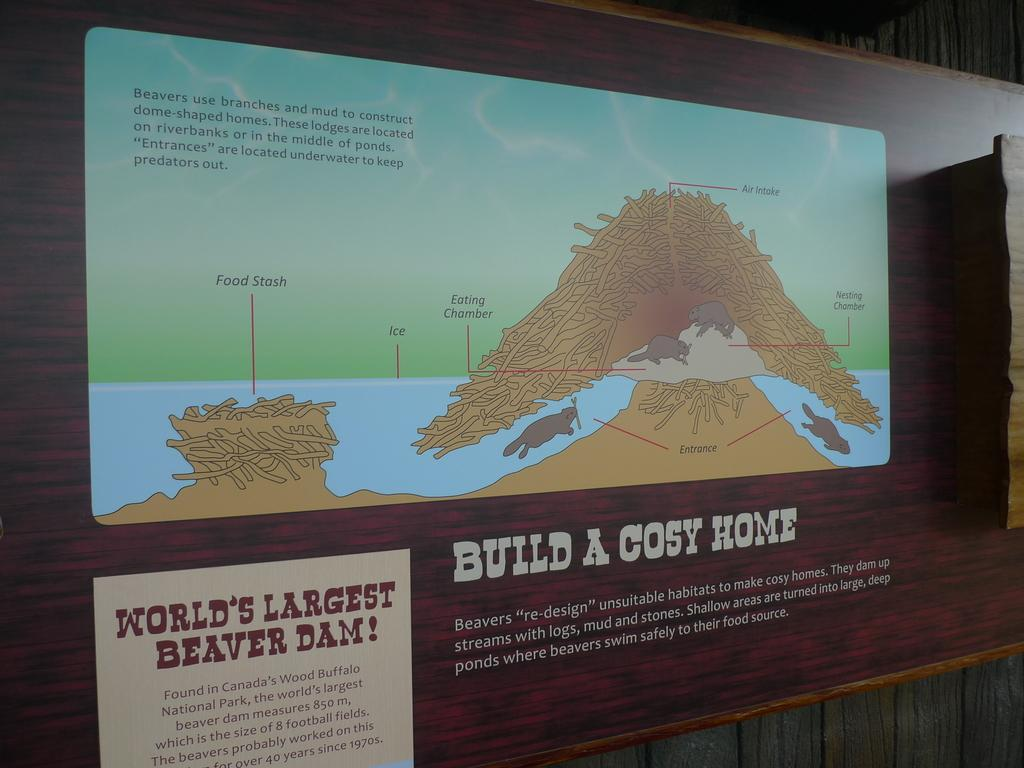<image>
Present a compact description of the photo's key features. The world's largest beaver dam can be found in Wood Buffalo National Park in Canada 